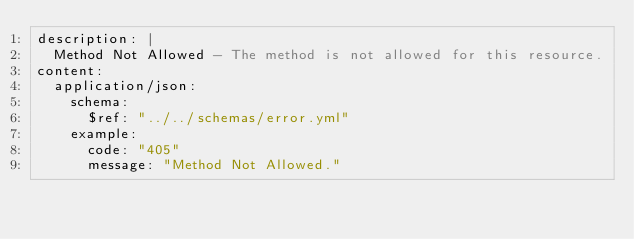<code> <loc_0><loc_0><loc_500><loc_500><_YAML_>description: |
  Method Not Allowed - The method is not allowed for this resource.
content:
  application/json:
    schema:
      $ref: "../../schemas/error.yml"
    example:
      code: "405"
      message: "Method Not Allowed."
</code> 